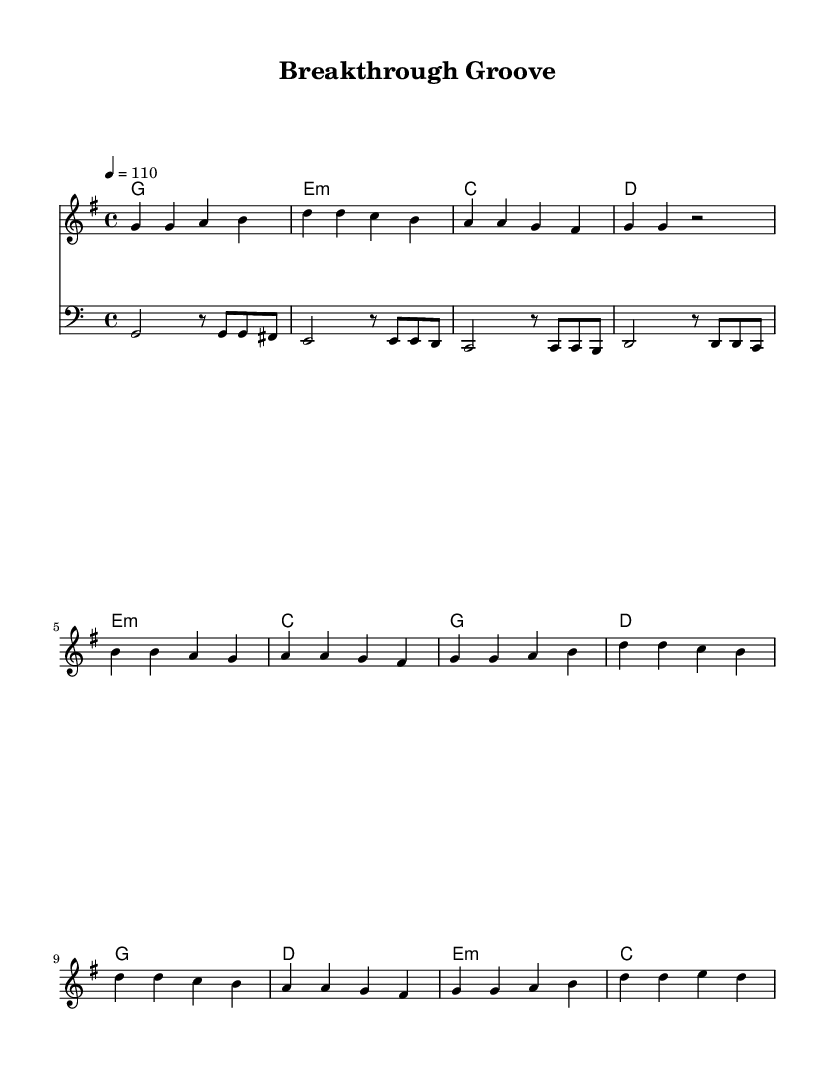What is the key signature of this music? The key signature is G major, which has one sharp (F#). This can be identified by looking at the beginning of the staff where the sharps are indicated.
Answer: G major What is the time signature of this music? The time signature is four-four, which means there are four beats per measure and the quarter note receives one beat. This is verified by the notation at the beginning of the staff.
Answer: Four-four What is the tempo marking of this music? The tempo marking is 110 beats per minute, as stated at the beginning of the piece next to the tempo indication.
Answer: 110 How many measures are in the verse section? The verse section consists of four measures, as counted by identifying the end of each measure in that section.
Answer: Four What chord is played in the first measure of the chorus? The first measure of the chorus features a G major chord, which is indicated by the letter G in the chord names above the staff.
Answer: G major Identify the rhythmic pattern of the bass line. The bass line features a rhythmic pattern that alternates between half notes and eighth notes, as noted by the notation in the bass staff. This can be observed by looking closely at the alignment of the note values.
Answer: Alternating half notes and eighth notes What sections are outlined in the structure of this composition? The structure includes verses, a pre-chorus, and a chorus, identifiable by the repetition and arrangement of the musical phrases in the sheet music.
Answer: Verse, Pre-Chorus, Chorus 